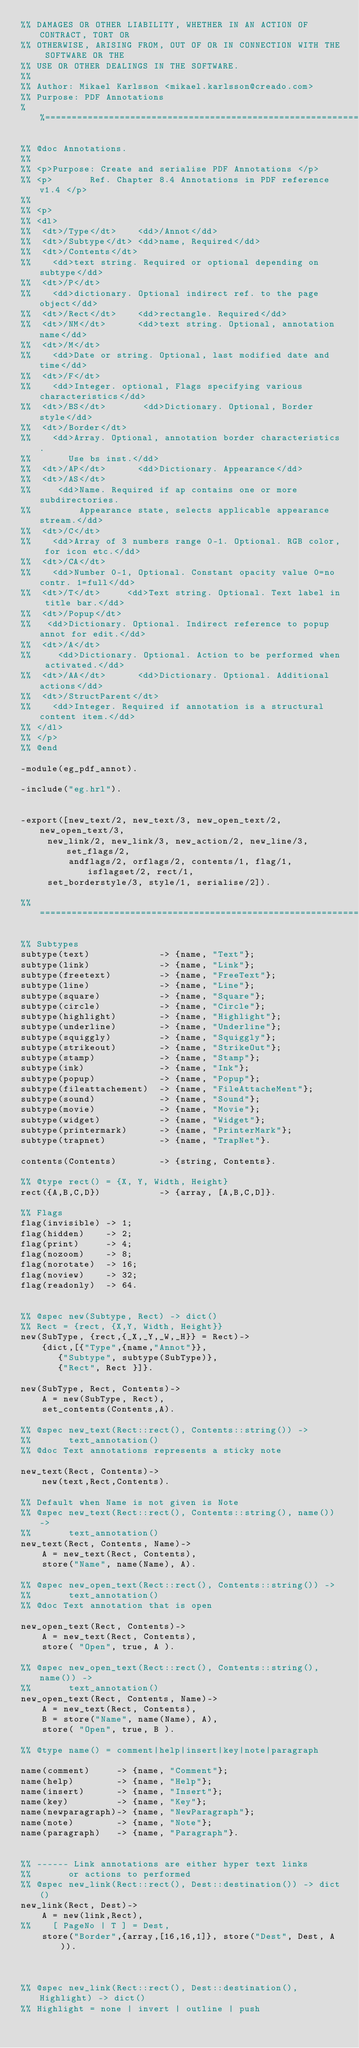<code> <loc_0><loc_0><loc_500><loc_500><_Erlang_>%% DAMAGES OR OTHER LIABILITY, WHETHER IN AN ACTION OF CONTRACT, TORT OR
%% OTHERWISE, ARISING FROM, OUT OF OR IN CONNECTION WITH THE SOFTWARE OR THE
%% USE OR OTHER DEALINGS IN THE SOFTWARE.
%%
%% Author: Mikael Karlsson <mikael.karlsson@creado.com>
%% Purpose: PDF Annotations
%%==========================================================================

%% @doc Annotations.
%%
%% <p>Purpose: Create and serialise PDF Annotations </p>
%% <p>       Ref. Chapter 8.4 Annotations in PDF reference v1.4 </p>
%% 
%% <p>
%% <dl>
%%  <dt>/Type</dt>    <dd>/Annot</dd>
%%  <dt>/Subtype</dt> <dd>name, Required</dd>
%%  <dt>/Contents</dt>
%%    <dd>text string. Required or optional depending on subtype</dd>
%%  <dt>/P</dt>       
%%    <dd>dictionary. Optional indirect ref. to the page object</dd>
%%  <dt>/Rect</dt>    <dd>rectangle. Required</dd>
%%  <dt>/NM</dt>      <dd>text string. Optional, annotation name</dd>
%%  <dt>/M</dt>       
%%    <dd>Date or string. Optional, last modified date and time</dd>
%%  <dt>/F</dt>       
%%    <dd>Integer. optional, Flags specifying various characteristics</dd>
%%  <dt>/BS</dt>       <dd>Dictionary. Optional, Border style</dd>
%%  <dt>/Border</dt>  
%%    <dd>Array. Optional, annotation border characteristics. 
%%       Use bs inst.</dd>
%%  <dt>/AP</dt>      <dd>Dictionary. Appearance</dd>
%%  <dt>/AS</dt>      
%%     <dd>Name. Required if ap contains one or more subdirectories.
%%         Appearance state, selects applicable appearance stream.</dd>
%%  <dt>/C</dt>       
%%    <dd>Array of 3 numbers range 0-1. Optional. RGB color, for icon etc.</dd>
%%  <dt>/CA</dt>      
%%    <dd>Number 0-1, Optional. Constant opacity value 0=no contr. 1=full</dd>
%%  <dt>/T</dt>     <dd>Text string. Optional. Text label in title bar.</dd>
%%  <dt>/Popup</dt>   
%%   <dd>Dictionary. Optional. Indirect reference to popup annot for edit.</dd>
%%  <dt>/A</dt>       
%%     <dd>Dictionary. Optional. Action to be performed when activated.</dd>
%%  <dt>/AA</dt>      <dd>Dictionary. Optional. Additional actions</dd>
%%  <dt>/StructParent</dt>
%%    <dd>Integer. Required if annotation is a structural content item.</dd>
%% </dl>
%% </p>
%% @end

-module(eg_pdf_annot).

-include("eg.hrl").


-export([new_text/2, new_text/3, new_open_text/2, new_open_text/3, 
	 new_link/2, new_link/3, new_action/2, new_line/3, set_flags/2,
         andflags/2, orflags/2, contents/1, flag/1, isflagset/2, rect/1,
	 set_borderstyle/3, style/1, serialise/2]).

%% ============================================================================

%% Subtypes
subtype(text)             -> {name, "Text"};
subtype(link)             -> {name, "Link"};
subtype(freetext)         -> {name, "FreeText"};
subtype(line)             -> {name, "Line"};
subtype(square)           -> {name, "Square"};
subtype(circle)           -> {name, "Circle"};
subtype(highlight)        -> {name, "Highlight"};
subtype(underline)        -> {name, "Underline"};
subtype(squiggly)         -> {name, "Squiggly"};
subtype(strikeout)        -> {name, "StrikeOut"};
subtype(stamp)            -> {name, "Stamp"};
subtype(ink)              -> {name, "Ink"};
subtype(popup)            -> {name, "Popup"};
subtype(fileattachement)  -> {name, "FileAttacheMent"};
subtype(sound)            -> {name, "Sound"};
subtype(movie)            -> {name, "Movie"};
subtype(widget)           -> {name, "Widget"};
subtype(printermark)      -> {name, "PrinterMark"};
subtype(trapnet)          -> {name, "TrapNet"}.

contents(Contents)        -> {string, Contents}.

%% @type rect() = {X, Y, Width, Height}
rect({A,B,C,D})           -> {array, [A,B,C,D]}.
    
%% Flags
flag(invisible) -> 1;
flag(hidden)    -> 2;
flag(print)     -> 4;
flag(nozoom)    -> 8;
flag(norotate)  -> 16;
flag(noview)    -> 32;
flag(readonly)  -> 64.


%% @spec new(Subtype, Rect) -> dict()
%% Rect = {rect, {X,Y, Width, Height}}
new(SubType, {rect,{_X,_Y,_W,_H}} = Rect)->
    {dict,[{"Type",{name,"Annot"}},
	   {"Subtype", subtype(SubType)}, 
	   {"Rect", Rect }]}.

new(SubType, Rect, Contents)->
    A = new(SubType, Rect),
    set_contents(Contents,A).

%% @spec new_text(Rect::rect(), Contents::string()) ->
%%       text_annotation()
%% @doc Text annotations represents a sticky note

new_text(Rect, Contents)->     
    new(text,Rect,Contents).

%% Default when Name is not given is Note
%% @spec new_text(Rect::rect(), Contents::string(), name()) ->
%%       text_annotation()
new_text(Rect, Contents, Name)-> 
    A = new_text(Rect, Contents),
    store("Name", name(Name), A).

%% @spec new_open_text(Rect::rect(), Contents::string()) ->
%%       text_annotation()
%% @doc Text annotation that is open

new_open_text(Rect, Contents)-> 
    A = new_text(Rect, Contents),
    store( "Open", true, A ).

%% @spec new_open_text(Rect::rect(), Contents::string(), name()) ->
%%       text_annotation()
new_open_text(Rect, Contents, Name)-> 
    A = new_text(Rect, Contents),
    B = store("Name", name(Name), A),
    store( "Open", true, B ).

%% @type name() = comment|help|insert|key|note|paragraph

name(comment)     -> {name, "Comment"};
name(help)        -> {name, "Help"};
name(insert)      -> {name, "Insert"};
name(key)         -> {name, "Key"};
name(newparagraph)-> {name, "NewParagraph"};
name(note)        -> {name, "Note"};
name(paragraph)   -> {name, "Paragraph"}.


%% ------ Link annotations are either hyper text links
%%       or actions to performed
%% @spec new_link(Rect::rect(), Dest::destination()) -> dict()
new_link(Rect, Dest)->     
    A = new(link,Rect),
%%    [ PageNo | T ] = Dest, 
    store("Border",{array,[16,16,1]}, store("Dest", Dest, A )).



%% @spec new_link(Rect::rect(), Dest::destination(), Highlight) -> dict()
%% Highlight = none | invert | outline | push
</code> 